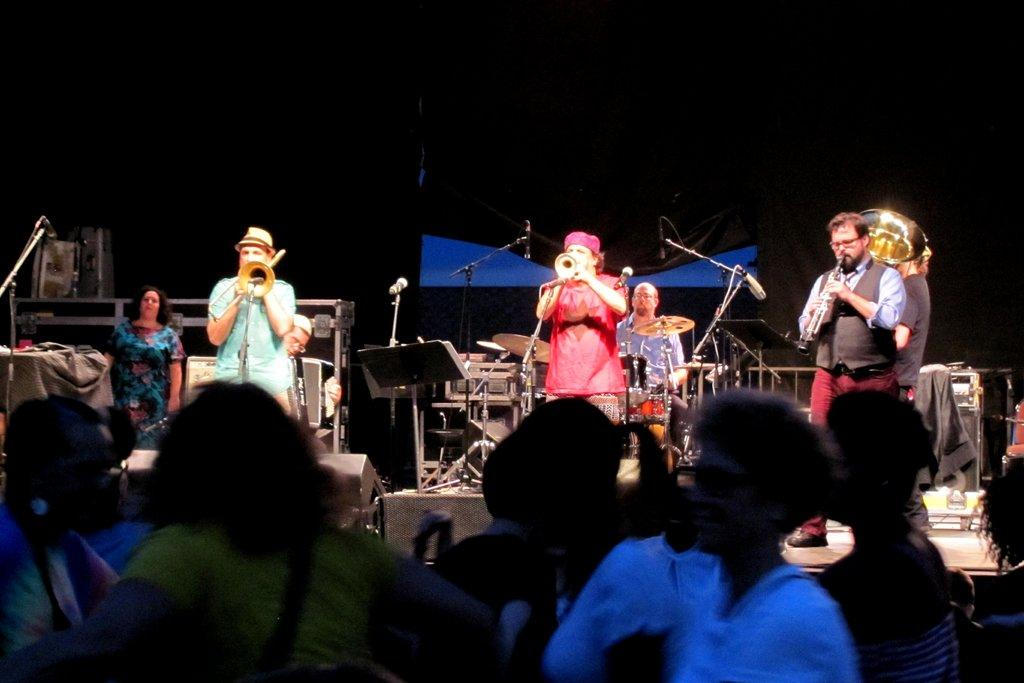How many people are playing musical instruments in the image? There are three persons in the image playing musical instruments. What is the purpose of the microphone in front of the musicians? The microphone is likely used for amplifying the sound of the musicians' instruments. What types of musical instruments can be seen in the image? There are musical instruments visible in the image, but their specific types are not mentioned in the facts. Can you describe the audience in the image? The presence of an audience in the image suggests that the musicians are performing for others. What type of step is required to make an adjustment to the impulse in the image? There is no mention of steps, adjustments, or impulses in the image, so this question cannot be answered definitively. 